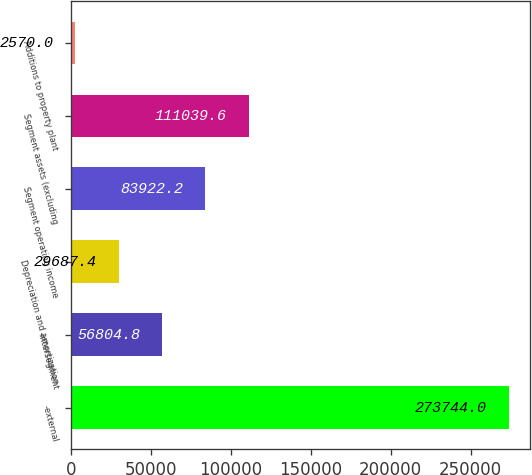<chart> <loc_0><loc_0><loc_500><loc_500><bar_chart><fcel>-external<fcel>-intersegment<fcel>Depreciation and amortization<fcel>Segment operating income<fcel>Segment assets (excluding<fcel>Additions to property plant<nl><fcel>273744<fcel>56804.8<fcel>29687.4<fcel>83922.2<fcel>111040<fcel>2570<nl></chart> 